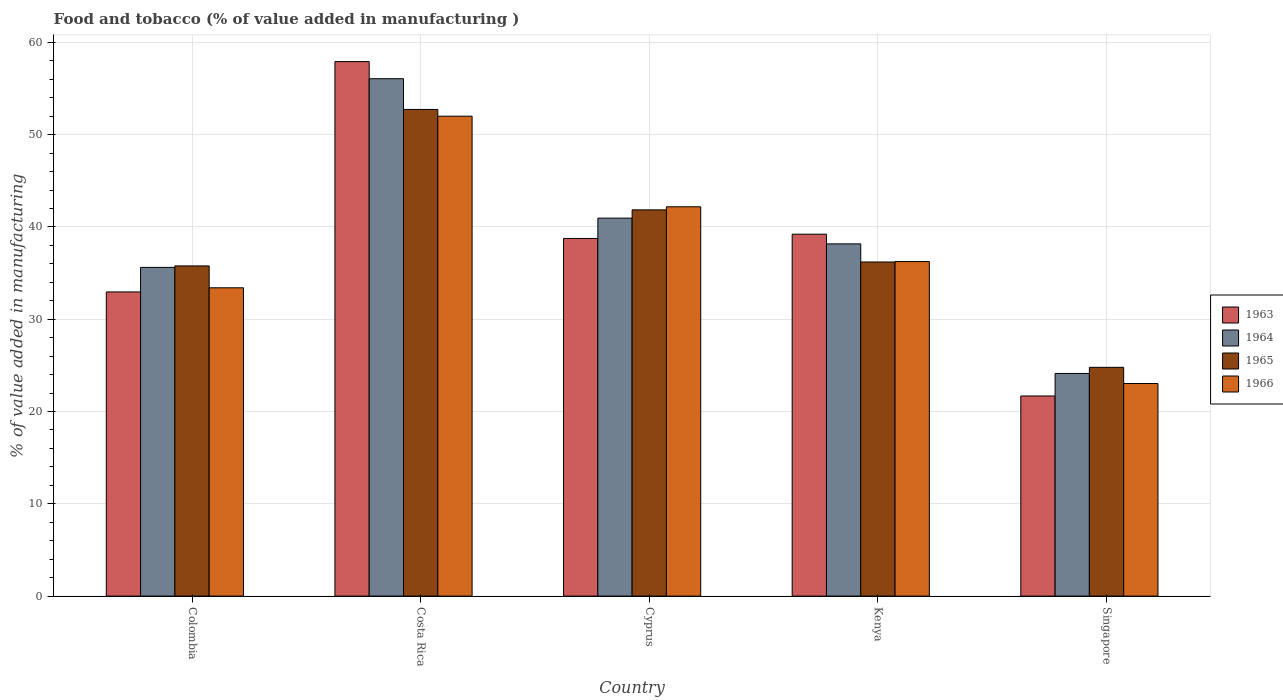How many different coloured bars are there?
Your answer should be compact. 4. Are the number of bars on each tick of the X-axis equal?
Keep it short and to the point. Yes. How many bars are there on the 4th tick from the right?
Your answer should be very brief. 4. What is the value added in manufacturing food and tobacco in 1966 in Colombia?
Your answer should be very brief. 33.41. Across all countries, what is the maximum value added in manufacturing food and tobacco in 1964?
Ensure brevity in your answer.  56.07. Across all countries, what is the minimum value added in manufacturing food and tobacco in 1966?
Make the answer very short. 23.04. In which country was the value added in manufacturing food and tobacco in 1965 maximum?
Provide a succinct answer. Costa Rica. In which country was the value added in manufacturing food and tobacco in 1966 minimum?
Offer a terse response. Singapore. What is the total value added in manufacturing food and tobacco in 1966 in the graph?
Your answer should be compact. 186.89. What is the difference between the value added in manufacturing food and tobacco in 1963 in Colombia and that in Costa Rica?
Provide a succinct answer. -24.96. What is the difference between the value added in manufacturing food and tobacco in 1965 in Singapore and the value added in manufacturing food and tobacco in 1966 in Colombia?
Your answer should be compact. -8.62. What is the average value added in manufacturing food and tobacco in 1965 per country?
Offer a terse response. 38.27. What is the difference between the value added in manufacturing food and tobacco of/in 1965 and value added in manufacturing food and tobacco of/in 1963 in Singapore?
Give a very brief answer. 3.1. What is the ratio of the value added in manufacturing food and tobacco in 1966 in Colombia to that in Kenya?
Make the answer very short. 0.92. Is the value added in manufacturing food and tobacco in 1963 in Costa Rica less than that in Singapore?
Your answer should be very brief. No. What is the difference between the highest and the second highest value added in manufacturing food and tobacco in 1966?
Ensure brevity in your answer.  -9.82. What is the difference between the highest and the lowest value added in manufacturing food and tobacco in 1963?
Your response must be concise. 36.23. In how many countries, is the value added in manufacturing food and tobacco in 1964 greater than the average value added in manufacturing food and tobacco in 1964 taken over all countries?
Provide a succinct answer. 2. What does the 2nd bar from the left in Kenya represents?
Offer a very short reply. 1964. What does the 2nd bar from the right in Colombia represents?
Your answer should be compact. 1965. How many bars are there?
Offer a terse response. 20. Are all the bars in the graph horizontal?
Offer a terse response. No. How many countries are there in the graph?
Your answer should be compact. 5. What is the difference between two consecutive major ticks on the Y-axis?
Offer a very short reply. 10. Does the graph contain any zero values?
Offer a very short reply. No. Where does the legend appear in the graph?
Your answer should be very brief. Center right. How many legend labels are there?
Give a very brief answer. 4. How are the legend labels stacked?
Make the answer very short. Vertical. What is the title of the graph?
Provide a succinct answer. Food and tobacco (% of value added in manufacturing ). What is the label or title of the Y-axis?
Provide a succinct answer. % of value added in manufacturing. What is the % of value added in manufacturing of 1963 in Colombia?
Ensure brevity in your answer.  32.96. What is the % of value added in manufacturing in 1964 in Colombia?
Your answer should be compact. 35.62. What is the % of value added in manufacturing in 1965 in Colombia?
Provide a short and direct response. 35.78. What is the % of value added in manufacturing in 1966 in Colombia?
Provide a short and direct response. 33.41. What is the % of value added in manufacturing in 1963 in Costa Rica?
Provide a short and direct response. 57.92. What is the % of value added in manufacturing in 1964 in Costa Rica?
Make the answer very short. 56.07. What is the % of value added in manufacturing in 1965 in Costa Rica?
Offer a terse response. 52.73. What is the % of value added in manufacturing in 1966 in Costa Rica?
Your answer should be compact. 52. What is the % of value added in manufacturing of 1963 in Cyprus?
Your response must be concise. 38.75. What is the % of value added in manufacturing of 1964 in Cyprus?
Ensure brevity in your answer.  40.96. What is the % of value added in manufacturing of 1965 in Cyprus?
Keep it short and to the point. 41.85. What is the % of value added in manufacturing of 1966 in Cyprus?
Offer a very short reply. 42.19. What is the % of value added in manufacturing of 1963 in Kenya?
Keep it short and to the point. 39.22. What is the % of value added in manufacturing of 1964 in Kenya?
Keep it short and to the point. 38.17. What is the % of value added in manufacturing of 1965 in Kenya?
Ensure brevity in your answer.  36.2. What is the % of value added in manufacturing of 1966 in Kenya?
Your answer should be compact. 36.25. What is the % of value added in manufacturing of 1963 in Singapore?
Keep it short and to the point. 21.69. What is the % of value added in manufacturing of 1964 in Singapore?
Keep it short and to the point. 24.13. What is the % of value added in manufacturing in 1965 in Singapore?
Ensure brevity in your answer.  24.79. What is the % of value added in manufacturing in 1966 in Singapore?
Your response must be concise. 23.04. Across all countries, what is the maximum % of value added in manufacturing in 1963?
Your answer should be compact. 57.92. Across all countries, what is the maximum % of value added in manufacturing in 1964?
Your answer should be compact. 56.07. Across all countries, what is the maximum % of value added in manufacturing in 1965?
Offer a very short reply. 52.73. Across all countries, what is the maximum % of value added in manufacturing in 1966?
Your answer should be very brief. 52. Across all countries, what is the minimum % of value added in manufacturing of 1963?
Offer a terse response. 21.69. Across all countries, what is the minimum % of value added in manufacturing in 1964?
Ensure brevity in your answer.  24.13. Across all countries, what is the minimum % of value added in manufacturing of 1965?
Provide a short and direct response. 24.79. Across all countries, what is the minimum % of value added in manufacturing in 1966?
Your answer should be compact. 23.04. What is the total % of value added in manufacturing of 1963 in the graph?
Give a very brief answer. 190.54. What is the total % of value added in manufacturing in 1964 in the graph?
Give a very brief answer. 194.94. What is the total % of value added in manufacturing in 1965 in the graph?
Your answer should be compact. 191.36. What is the total % of value added in manufacturing of 1966 in the graph?
Your answer should be very brief. 186.89. What is the difference between the % of value added in manufacturing of 1963 in Colombia and that in Costa Rica?
Give a very brief answer. -24.96. What is the difference between the % of value added in manufacturing in 1964 in Colombia and that in Costa Rica?
Your answer should be very brief. -20.45. What is the difference between the % of value added in manufacturing of 1965 in Colombia and that in Costa Rica?
Keep it short and to the point. -16.95. What is the difference between the % of value added in manufacturing of 1966 in Colombia and that in Costa Rica?
Give a very brief answer. -18.59. What is the difference between the % of value added in manufacturing in 1963 in Colombia and that in Cyprus?
Offer a terse response. -5.79. What is the difference between the % of value added in manufacturing of 1964 in Colombia and that in Cyprus?
Ensure brevity in your answer.  -5.34. What is the difference between the % of value added in manufacturing of 1965 in Colombia and that in Cyprus?
Give a very brief answer. -6.07. What is the difference between the % of value added in manufacturing in 1966 in Colombia and that in Cyprus?
Ensure brevity in your answer.  -8.78. What is the difference between the % of value added in manufacturing of 1963 in Colombia and that in Kenya?
Make the answer very short. -6.26. What is the difference between the % of value added in manufacturing of 1964 in Colombia and that in Kenya?
Ensure brevity in your answer.  -2.55. What is the difference between the % of value added in manufacturing in 1965 in Colombia and that in Kenya?
Give a very brief answer. -0.42. What is the difference between the % of value added in manufacturing of 1966 in Colombia and that in Kenya?
Make the answer very short. -2.84. What is the difference between the % of value added in manufacturing of 1963 in Colombia and that in Singapore?
Give a very brief answer. 11.27. What is the difference between the % of value added in manufacturing of 1964 in Colombia and that in Singapore?
Offer a very short reply. 11.49. What is the difference between the % of value added in manufacturing of 1965 in Colombia and that in Singapore?
Ensure brevity in your answer.  10.99. What is the difference between the % of value added in manufacturing of 1966 in Colombia and that in Singapore?
Keep it short and to the point. 10.37. What is the difference between the % of value added in manufacturing of 1963 in Costa Rica and that in Cyprus?
Your answer should be compact. 19.17. What is the difference between the % of value added in manufacturing of 1964 in Costa Rica and that in Cyprus?
Your response must be concise. 15.11. What is the difference between the % of value added in manufacturing in 1965 in Costa Rica and that in Cyprus?
Make the answer very short. 10.88. What is the difference between the % of value added in manufacturing of 1966 in Costa Rica and that in Cyprus?
Ensure brevity in your answer.  9.82. What is the difference between the % of value added in manufacturing in 1963 in Costa Rica and that in Kenya?
Your response must be concise. 18.7. What is the difference between the % of value added in manufacturing of 1964 in Costa Rica and that in Kenya?
Provide a short and direct response. 17.9. What is the difference between the % of value added in manufacturing of 1965 in Costa Rica and that in Kenya?
Offer a terse response. 16.53. What is the difference between the % of value added in manufacturing of 1966 in Costa Rica and that in Kenya?
Your answer should be very brief. 15.75. What is the difference between the % of value added in manufacturing in 1963 in Costa Rica and that in Singapore?
Ensure brevity in your answer.  36.23. What is the difference between the % of value added in manufacturing in 1964 in Costa Rica and that in Singapore?
Your response must be concise. 31.94. What is the difference between the % of value added in manufacturing of 1965 in Costa Rica and that in Singapore?
Your answer should be very brief. 27.94. What is the difference between the % of value added in manufacturing in 1966 in Costa Rica and that in Singapore?
Offer a very short reply. 28.97. What is the difference between the % of value added in manufacturing in 1963 in Cyprus and that in Kenya?
Ensure brevity in your answer.  -0.46. What is the difference between the % of value added in manufacturing in 1964 in Cyprus and that in Kenya?
Provide a short and direct response. 2.79. What is the difference between the % of value added in manufacturing of 1965 in Cyprus and that in Kenya?
Your answer should be very brief. 5.65. What is the difference between the % of value added in manufacturing in 1966 in Cyprus and that in Kenya?
Keep it short and to the point. 5.93. What is the difference between the % of value added in manufacturing of 1963 in Cyprus and that in Singapore?
Provide a short and direct response. 17.07. What is the difference between the % of value added in manufacturing of 1964 in Cyprus and that in Singapore?
Your answer should be compact. 16.83. What is the difference between the % of value added in manufacturing in 1965 in Cyprus and that in Singapore?
Your answer should be compact. 17.06. What is the difference between the % of value added in manufacturing in 1966 in Cyprus and that in Singapore?
Your answer should be very brief. 19.15. What is the difference between the % of value added in manufacturing in 1963 in Kenya and that in Singapore?
Your response must be concise. 17.53. What is the difference between the % of value added in manufacturing in 1964 in Kenya and that in Singapore?
Make the answer very short. 14.04. What is the difference between the % of value added in manufacturing of 1965 in Kenya and that in Singapore?
Make the answer very short. 11.41. What is the difference between the % of value added in manufacturing of 1966 in Kenya and that in Singapore?
Provide a succinct answer. 13.22. What is the difference between the % of value added in manufacturing of 1963 in Colombia and the % of value added in manufacturing of 1964 in Costa Rica?
Offer a terse response. -23.11. What is the difference between the % of value added in manufacturing in 1963 in Colombia and the % of value added in manufacturing in 1965 in Costa Rica?
Make the answer very short. -19.77. What is the difference between the % of value added in manufacturing in 1963 in Colombia and the % of value added in manufacturing in 1966 in Costa Rica?
Give a very brief answer. -19.04. What is the difference between the % of value added in manufacturing of 1964 in Colombia and the % of value added in manufacturing of 1965 in Costa Rica?
Offer a terse response. -17.11. What is the difference between the % of value added in manufacturing of 1964 in Colombia and the % of value added in manufacturing of 1966 in Costa Rica?
Give a very brief answer. -16.38. What is the difference between the % of value added in manufacturing in 1965 in Colombia and the % of value added in manufacturing in 1966 in Costa Rica?
Provide a short and direct response. -16.22. What is the difference between the % of value added in manufacturing of 1963 in Colombia and the % of value added in manufacturing of 1964 in Cyprus?
Ensure brevity in your answer.  -8. What is the difference between the % of value added in manufacturing in 1963 in Colombia and the % of value added in manufacturing in 1965 in Cyprus?
Give a very brief answer. -8.89. What is the difference between the % of value added in manufacturing in 1963 in Colombia and the % of value added in manufacturing in 1966 in Cyprus?
Offer a terse response. -9.23. What is the difference between the % of value added in manufacturing in 1964 in Colombia and the % of value added in manufacturing in 1965 in Cyprus?
Keep it short and to the point. -6.23. What is the difference between the % of value added in manufacturing in 1964 in Colombia and the % of value added in manufacturing in 1966 in Cyprus?
Make the answer very short. -6.57. What is the difference between the % of value added in manufacturing in 1965 in Colombia and the % of value added in manufacturing in 1966 in Cyprus?
Ensure brevity in your answer.  -6.41. What is the difference between the % of value added in manufacturing in 1963 in Colombia and the % of value added in manufacturing in 1964 in Kenya?
Your response must be concise. -5.21. What is the difference between the % of value added in manufacturing of 1963 in Colombia and the % of value added in manufacturing of 1965 in Kenya?
Offer a very short reply. -3.24. What is the difference between the % of value added in manufacturing in 1963 in Colombia and the % of value added in manufacturing in 1966 in Kenya?
Your answer should be very brief. -3.29. What is the difference between the % of value added in manufacturing of 1964 in Colombia and the % of value added in manufacturing of 1965 in Kenya?
Keep it short and to the point. -0.58. What is the difference between the % of value added in manufacturing of 1964 in Colombia and the % of value added in manufacturing of 1966 in Kenya?
Your answer should be compact. -0.63. What is the difference between the % of value added in manufacturing in 1965 in Colombia and the % of value added in manufacturing in 1966 in Kenya?
Give a very brief answer. -0.47. What is the difference between the % of value added in manufacturing in 1963 in Colombia and the % of value added in manufacturing in 1964 in Singapore?
Give a very brief answer. 8.83. What is the difference between the % of value added in manufacturing of 1963 in Colombia and the % of value added in manufacturing of 1965 in Singapore?
Your response must be concise. 8.17. What is the difference between the % of value added in manufacturing in 1963 in Colombia and the % of value added in manufacturing in 1966 in Singapore?
Give a very brief answer. 9.92. What is the difference between the % of value added in manufacturing in 1964 in Colombia and the % of value added in manufacturing in 1965 in Singapore?
Offer a terse response. 10.83. What is the difference between the % of value added in manufacturing of 1964 in Colombia and the % of value added in manufacturing of 1966 in Singapore?
Your response must be concise. 12.58. What is the difference between the % of value added in manufacturing of 1965 in Colombia and the % of value added in manufacturing of 1966 in Singapore?
Make the answer very short. 12.74. What is the difference between the % of value added in manufacturing of 1963 in Costa Rica and the % of value added in manufacturing of 1964 in Cyprus?
Provide a succinct answer. 16.96. What is the difference between the % of value added in manufacturing in 1963 in Costa Rica and the % of value added in manufacturing in 1965 in Cyprus?
Your response must be concise. 16.07. What is the difference between the % of value added in manufacturing of 1963 in Costa Rica and the % of value added in manufacturing of 1966 in Cyprus?
Provide a short and direct response. 15.73. What is the difference between the % of value added in manufacturing in 1964 in Costa Rica and the % of value added in manufacturing in 1965 in Cyprus?
Your answer should be compact. 14.21. What is the difference between the % of value added in manufacturing of 1964 in Costa Rica and the % of value added in manufacturing of 1966 in Cyprus?
Your answer should be very brief. 13.88. What is the difference between the % of value added in manufacturing of 1965 in Costa Rica and the % of value added in manufacturing of 1966 in Cyprus?
Your answer should be very brief. 10.55. What is the difference between the % of value added in manufacturing of 1963 in Costa Rica and the % of value added in manufacturing of 1964 in Kenya?
Your answer should be very brief. 19.75. What is the difference between the % of value added in manufacturing in 1963 in Costa Rica and the % of value added in manufacturing in 1965 in Kenya?
Keep it short and to the point. 21.72. What is the difference between the % of value added in manufacturing of 1963 in Costa Rica and the % of value added in manufacturing of 1966 in Kenya?
Provide a short and direct response. 21.67. What is the difference between the % of value added in manufacturing in 1964 in Costa Rica and the % of value added in manufacturing in 1965 in Kenya?
Provide a short and direct response. 19.86. What is the difference between the % of value added in manufacturing of 1964 in Costa Rica and the % of value added in manufacturing of 1966 in Kenya?
Your answer should be very brief. 19.81. What is the difference between the % of value added in manufacturing in 1965 in Costa Rica and the % of value added in manufacturing in 1966 in Kenya?
Keep it short and to the point. 16.48. What is the difference between the % of value added in manufacturing of 1963 in Costa Rica and the % of value added in manufacturing of 1964 in Singapore?
Your answer should be very brief. 33.79. What is the difference between the % of value added in manufacturing in 1963 in Costa Rica and the % of value added in manufacturing in 1965 in Singapore?
Your answer should be very brief. 33.13. What is the difference between the % of value added in manufacturing in 1963 in Costa Rica and the % of value added in manufacturing in 1966 in Singapore?
Your response must be concise. 34.88. What is the difference between the % of value added in manufacturing in 1964 in Costa Rica and the % of value added in manufacturing in 1965 in Singapore?
Your answer should be compact. 31.28. What is the difference between the % of value added in manufacturing of 1964 in Costa Rica and the % of value added in manufacturing of 1966 in Singapore?
Your response must be concise. 33.03. What is the difference between the % of value added in manufacturing in 1965 in Costa Rica and the % of value added in manufacturing in 1966 in Singapore?
Keep it short and to the point. 29.7. What is the difference between the % of value added in manufacturing in 1963 in Cyprus and the % of value added in manufacturing in 1964 in Kenya?
Make the answer very short. 0.59. What is the difference between the % of value added in manufacturing of 1963 in Cyprus and the % of value added in manufacturing of 1965 in Kenya?
Your answer should be very brief. 2.55. What is the difference between the % of value added in manufacturing in 1963 in Cyprus and the % of value added in manufacturing in 1966 in Kenya?
Your answer should be compact. 2.5. What is the difference between the % of value added in manufacturing of 1964 in Cyprus and the % of value added in manufacturing of 1965 in Kenya?
Your answer should be compact. 4.75. What is the difference between the % of value added in manufacturing of 1964 in Cyprus and the % of value added in manufacturing of 1966 in Kenya?
Give a very brief answer. 4.7. What is the difference between the % of value added in manufacturing in 1965 in Cyprus and the % of value added in manufacturing in 1966 in Kenya?
Make the answer very short. 5.6. What is the difference between the % of value added in manufacturing of 1963 in Cyprus and the % of value added in manufacturing of 1964 in Singapore?
Your response must be concise. 14.63. What is the difference between the % of value added in manufacturing in 1963 in Cyprus and the % of value added in manufacturing in 1965 in Singapore?
Your answer should be very brief. 13.96. What is the difference between the % of value added in manufacturing in 1963 in Cyprus and the % of value added in manufacturing in 1966 in Singapore?
Offer a very short reply. 15.72. What is the difference between the % of value added in manufacturing in 1964 in Cyprus and the % of value added in manufacturing in 1965 in Singapore?
Keep it short and to the point. 16.17. What is the difference between the % of value added in manufacturing in 1964 in Cyprus and the % of value added in manufacturing in 1966 in Singapore?
Offer a terse response. 17.92. What is the difference between the % of value added in manufacturing in 1965 in Cyprus and the % of value added in manufacturing in 1966 in Singapore?
Your response must be concise. 18.82. What is the difference between the % of value added in manufacturing in 1963 in Kenya and the % of value added in manufacturing in 1964 in Singapore?
Your answer should be very brief. 15.09. What is the difference between the % of value added in manufacturing of 1963 in Kenya and the % of value added in manufacturing of 1965 in Singapore?
Keep it short and to the point. 14.43. What is the difference between the % of value added in manufacturing of 1963 in Kenya and the % of value added in manufacturing of 1966 in Singapore?
Your answer should be very brief. 16.18. What is the difference between the % of value added in manufacturing of 1964 in Kenya and the % of value added in manufacturing of 1965 in Singapore?
Provide a short and direct response. 13.38. What is the difference between the % of value added in manufacturing of 1964 in Kenya and the % of value added in manufacturing of 1966 in Singapore?
Offer a terse response. 15.13. What is the difference between the % of value added in manufacturing of 1965 in Kenya and the % of value added in manufacturing of 1966 in Singapore?
Your response must be concise. 13.17. What is the average % of value added in manufacturing of 1963 per country?
Your answer should be compact. 38.11. What is the average % of value added in manufacturing in 1964 per country?
Keep it short and to the point. 38.99. What is the average % of value added in manufacturing in 1965 per country?
Your answer should be compact. 38.27. What is the average % of value added in manufacturing of 1966 per country?
Your response must be concise. 37.38. What is the difference between the % of value added in manufacturing of 1963 and % of value added in manufacturing of 1964 in Colombia?
Provide a succinct answer. -2.66. What is the difference between the % of value added in manufacturing in 1963 and % of value added in manufacturing in 1965 in Colombia?
Make the answer very short. -2.82. What is the difference between the % of value added in manufacturing of 1963 and % of value added in manufacturing of 1966 in Colombia?
Make the answer very short. -0.45. What is the difference between the % of value added in manufacturing of 1964 and % of value added in manufacturing of 1965 in Colombia?
Ensure brevity in your answer.  -0.16. What is the difference between the % of value added in manufacturing of 1964 and % of value added in manufacturing of 1966 in Colombia?
Make the answer very short. 2.21. What is the difference between the % of value added in manufacturing in 1965 and % of value added in manufacturing in 1966 in Colombia?
Make the answer very short. 2.37. What is the difference between the % of value added in manufacturing of 1963 and % of value added in manufacturing of 1964 in Costa Rica?
Offer a very short reply. 1.85. What is the difference between the % of value added in manufacturing of 1963 and % of value added in manufacturing of 1965 in Costa Rica?
Offer a terse response. 5.19. What is the difference between the % of value added in manufacturing of 1963 and % of value added in manufacturing of 1966 in Costa Rica?
Your answer should be very brief. 5.92. What is the difference between the % of value added in manufacturing of 1964 and % of value added in manufacturing of 1965 in Costa Rica?
Your answer should be very brief. 3.33. What is the difference between the % of value added in manufacturing of 1964 and % of value added in manufacturing of 1966 in Costa Rica?
Your response must be concise. 4.06. What is the difference between the % of value added in manufacturing in 1965 and % of value added in manufacturing in 1966 in Costa Rica?
Your answer should be very brief. 0.73. What is the difference between the % of value added in manufacturing in 1963 and % of value added in manufacturing in 1964 in Cyprus?
Your answer should be compact. -2.2. What is the difference between the % of value added in manufacturing in 1963 and % of value added in manufacturing in 1965 in Cyprus?
Offer a terse response. -3.1. What is the difference between the % of value added in manufacturing of 1963 and % of value added in manufacturing of 1966 in Cyprus?
Provide a short and direct response. -3.43. What is the difference between the % of value added in manufacturing in 1964 and % of value added in manufacturing in 1965 in Cyprus?
Offer a terse response. -0.9. What is the difference between the % of value added in manufacturing of 1964 and % of value added in manufacturing of 1966 in Cyprus?
Your answer should be very brief. -1.23. What is the difference between the % of value added in manufacturing of 1963 and % of value added in manufacturing of 1964 in Kenya?
Your response must be concise. 1.05. What is the difference between the % of value added in manufacturing in 1963 and % of value added in manufacturing in 1965 in Kenya?
Give a very brief answer. 3.01. What is the difference between the % of value added in manufacturing of 1963 and % of value added in manufacturing of 1966 in Kenya?
Keep it short and to the point. 2.96. What is the difference between the % of value added in manufacturing in 1964 and % of value added in manufacturing in 1965 in Kenya?
Offer a very short reply. 1.96. What is the difference between the % of value added in manufacturing of 1964 and % of value added in manufacturing of 1966 in Kenya?
Provide a short and direct response. 1.91. What is the difference between the % of value added in manufacturing of 1963 and % of value added in manufacturing of 1964 in Singapore?
Your answer should be very brief. -2.44. What is the difference between the % of value added in manufacturing in 1963 and % of value added in manufacturing in 1965 in Singapore?
Offer a very short reply. -3.1. What is the difference between the % of value added in manufacturing in 1963 and % of value added in manufacturing in 1966 in Singapore?
Your answer should be very brief. -1.35. What is the difference between the % of value added in manufacturing of 1964 and % of value added in manufacturing of 1965 in Singapore?
Ensure brevity in your answer.  -0.66. What is the difference between the % of value added in manufacturing in 1964 and % of value added in manufacturing in 1966 in Singapore?
Offer a very short reply. 1.09. What is the difference between the % of value added in manufacturing of 1965 and % of value added in manufacturing of 1966 in Singapore?
Your answer should be compact. 1.75. What is the ratio of the % of value added in manufacturing in 1963 in Colombia to that in Costa Rica?
Your answer should be compact. 0.57. What is the ratio of the % of value added in manufacturing in 1964 in Colombia to that in Costa Rica?
Offer a terse response. 0.64. What is the ratio of the % of value added in manufacturing in 1965 in Colombia to that in Costa Rica?
Keep it short and to the point. 0.68. What is the ratio of the % of value added in manufacturing of 1966 in Colombia to that in Costa Rica?
Ensure brevity in your answer.  0.64. What is the ratio of the % of value added in manufacturing of 1963 in Colombia to that in Cyprus?
Make the answer very short. 0.85. What is the ratio of the % of value added in manufacturing of 1964 in Colombia to that in Cyprus?
Your answer should be very brief. 0.87. What is the ratio of the % of value added in manufacturing in 1965 in Colombia to that in Cyprus?
Make the answer very short. 0.85. What is the ratio of the % of value added in manufacturing of 1966 in Colombia to that in Cyprus?
Your response must be concise. 0.79. What is the ratio of the % of value added in manufacturing of 1963 in Colombia to that in Kenya?
Provide a succinct answer. 0.84. What is the ratio of the % of value added in manufacturing in 1964 in Colombia to that in Kenya?
Make the answer very short. 0.93. What is the ratio of the % of value added in manufacturing in 1965 in Colombia to that in Kenya?
Your response must be concise. 0.99. What is the ratio of the % of value added in manufacturing in 1966 in Colombia to that in Kenya?
Give a very brief answer. 0.92. What is the ratio of the % of value added in manufacturing in 1963 in Colombia to that in Singapore?
Ensure brevity in your answer.  1.52. What is the ratio of the % of value added in manufacturing in 1964 in Colombia to that in Singapore?
Keep it short and to the point. 1.48. What is the ratio of the % of value added in manufacturing in 1965 in Colombia to that in Singapore?
Your response must be concise. 1.44. What is the ratio of the % of value added in manufacturing of 1966 in Colombia to that in Singapore?
Your answer should be very brief. 1.45. What is the ratio of the % of value added in manufacturing in 1963 in Costa Rica to that in Cyprus?
Your response must be concise. 1.49. What is the ratio of the % of value added in manufacturing of 1964 in Costa Rica to that in Cyprus?
Give a very brief answer. 1.37. What is the ratio of the % of value added in manufacturing in 1965 in Costa Rica to that in Cyprus?
Your response must be concise. 1.26. What is the ratio of the % of value added in manufacturing of 1966 in Costa Rica to that in Cyprus?
Provide a succinct answer. 1.23. What is the ratio of the % of value added in manufacturing in 1963 in Costa Rica to that in Kenya?
Your answer should be very brief. 1.48. What is the ratio of the % of value added in manufacturing of 1964 in Costa Rica to that in Kenya?
Provide a short and direct response. 1.47. What is the ratio of the % of value added in manufacturing in 1965 in Costa Rica to that in Kenya?
Make the answer very short. 1.46. What is the ratio of the % of value added in manufacturing in 1966 in Costa Rica to that in Kenya?
Provide a succinct answer. 1.43. What is the ratio of the % of value added in manufacturing in 1963 in Costa Rica to that in Singapore?
Your response must be concise. 2.67. What is the ratio of the % of value added in manufacturing in 1964 in Costa Rica to that in Singapore?
Provide a succinct answer. 2.32. What is the ratio of the % of value added in manufacturing of 1965 in Costa Rica to that in Singapore?
Ensure brevity in your answer.  2.13. What is the ratio of the % of value added in manufacturing of 1966 in Costa Rica to that in Singapore?
Your answer should be very brief. 2.26. What is the ratio of the % of value added in manufacturing of 1963 in Cyprus to that in Kenya?
Provide a short and direct response. 0.99. What is the ratio of the % of value added in manufacturing of 1964 in Cyprus to that in Kenya?
Keep it short and to the point. 1.07. What is the ratio of the % of value added in manufacturing of 1965 in Cyprus to that in Kenya?
Provide a short and direct response. 1.16. What is the ratio of the % of value added in manufacturing in 1966 in Cyprus to that in Kenya?
Your answer should be very brief. 1.16. What is the ratio of the % of value added in manufacturing of 1963 in Cyprus to that in Singapore?
Ensure brevity in your answer.  1.79. What is the ratio of the % of value added in manufacturing in 1964 in Cyprus to that in Singapore?
Offer a terse response. 1.7. What is the ratio of the % of value added in manufacturing of 1965 in Cyprus to that in Singapore?
Your response must be concise. 1.69. What is the ratio of the % of value added in manufacturing in 1966 in Cyprus to that in Singapore?
Ensure brevity in your answer.  1.83. What is the ratio of the % of value added in manufacturing of 1963 in Kenya to that in Singapore?
Your response must be concise. 1.81. What is the ratio of the % of value added in manufacturing of 1964 in Kenya to that in Singapore?
Your answer should be compact. 1.58. What is the ratio of the % of value added in manufacturing of 1965 in Kenya to that in Singapore?
Ensure brevity in your answer.  1.46. What is the ratio of the % of value added in manufacturing in 1966 in Kenya to that in Singapore?
Provide a succinct answer. 1.57. What is the difference between the highest and the second highest % of value added in manufacturing of 1963?
Offer a terse response. 18.7. What is the difference between the highest and the second highest % of value added in manufacturing in 1964?
Give a very brief answer. 15.11. What is the difference between the highest and the second highest % of value added in manufacturing in 1965?
Give a very brief answer. 10.88. What is the difference between the highest and the second highest % of value added in manufacturing of 1966?
Offer a very short reply. 9.82. What is the difference between the highest and the lowest % of value added in manufacturing in 1963?
Make the answer very short. 36.23. What is the difference between the highest and the lowest % of value added in manufacturing of 1964?
Offer a terse response. 31.94. What is the difference between the highest and the lowest % of value added in manufacturing of 1965?
Offer a very short reply. 27.94. What is the difference between the highest and the lowest % of value added in manufacturing in 1966?
Your answer should be compact. 28.97. 